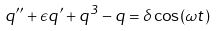Convert formula to latex. <formula><loc_0><loc_0><loc_500><loc_500>q ^ { \prime \prime } + \epsilon q ^ { \prime } + q ^ { 3 } - q = \delta \cos ( \omega t )</formula> 